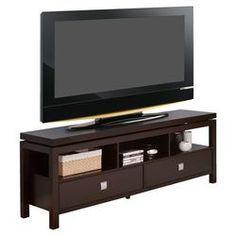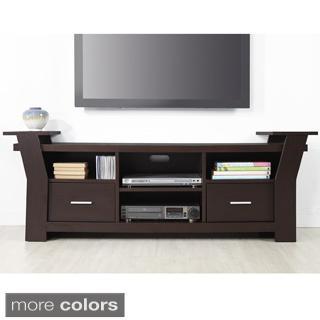The first image is the image on the left, the second image is the image on the right. For the images displayed, is the sentence "The TV stands on the left and right are similar styles, with the same dark wood and approximately the same configuration of compartments." factually correct? Answer yes or no. Yes. The first image is the image on the left, the second image is the image on the right. For the images displayed, is the sentence "A flat screen television is sitting against a wall on a low wooden cabinet that has four glass-fronted doors." factually correct? Answer yes or no. No. 